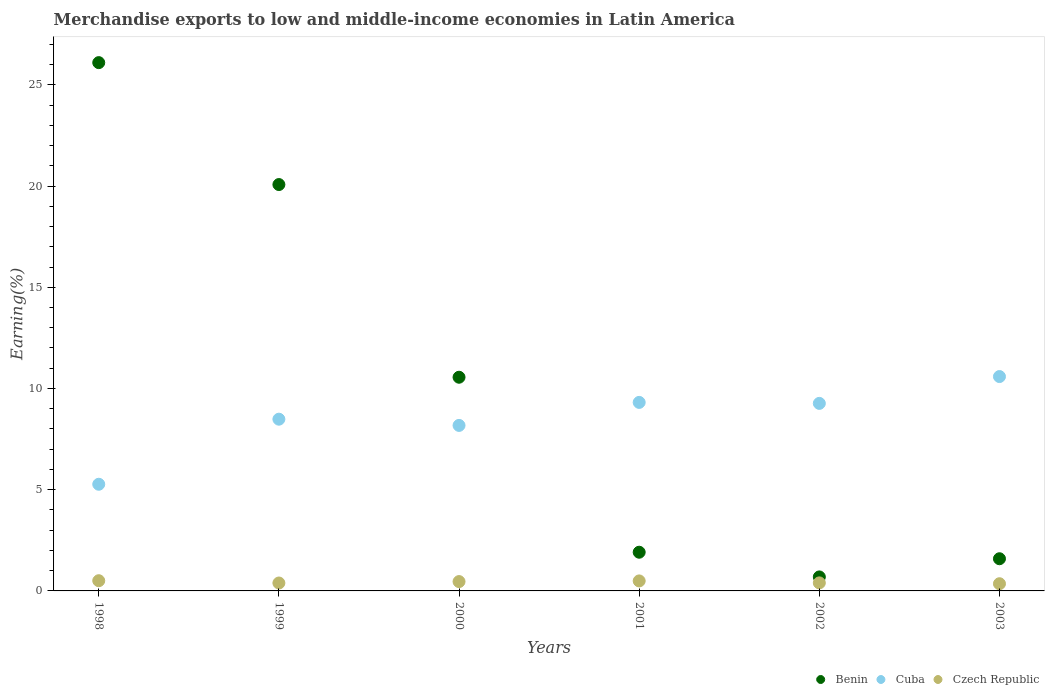Is the number of dotlines equal to the number of legend labels?
Keep it short and to the point. Yes. What is the percentage of amount earned from merchandise exports in Benin in 2000?
Make the answer very short. 10.56. Across all years, what is the maximum percentage of amount earned from merchandise exports in Czech Republic?
Offer a terse response. 0.5. Across all years, what is the minimum percentage of amount earned from merchandise exports in Cuba?
Make the answer very short. 5.27. In which year was the percentage of amount earned from merchandise exports in Czech Republic maximum?
Your response must be concise. 1998. What is the total percentage of amount earned from merchandise exports in Cuba in the graph?
Your response must be concise. 51.09. What is the difference between the percentage of amount earned from merchandise exports in Cuba in 1999 and that in 2000?
Offer a very short reply. 0.31. What is the difference between the percentage of amount earned from merchandise exports in Czech Republic in 2000 and the percentage of amount earned from merchandise exports in Benin in 2001?
Offer a very short reply. -1.45. What is the average percentage of amount earned from merchandise exports in Benin per year?
Your answer should be compact. 10.15. In the year 2001, what is the difference between the percentage of amount earned from merchandise exports in Benin and percentage of amount earned from merchandise exports in Czech Republic?
Provide a short and direct response. 1.42. In how many years, is the percentage of amount earned from merchandise exports in Benin greater than 5 %?
Give a very brief answer. 3. What is the ratio of the percentage of amount earned from merchandise exports in Czech Republic in 1999 to that in 2002?
Provide a succinct answer. 0.98. Is the difference between the percentage of amount earned from merchandise exports in Benin in 1998 and 1999 greater than the difference between the percentage of amount earned from merchandise exports in Czech Republic in 1998 and 1999?
Your answer should be compact. Yes. What is the difference between the highest and the second highest percentage of amount earned from merchandise exports in Benin?
Your answer should be compact. 6.02. What is the difference between the highest and the lowest percentage of amount earned from merchandise exports in Czech Republic?
Your answer should be compact. 0.15. Is the sum of the percentage of amount earned from merchandise exports in Cuba in 2002 and 2003 greater than the maximum percentage of amount earned from merchandise exports in Czech Republic across all years?
Ensure brevity in your answer.  Yes. Is it the case that in every year, the sum of the percentage of amount earned from merchandise exports in Cuba and percentage of amount earned from merchandise exports in Benin  is greater than the percentage of amount earned from merchandise exports in Czech Republic?
Your response must be concise. Yes. How many dotlines are there?
Provide a short and direct response. 3. What is the difference between two consecutive major ticks on the Y-axis?
Give a very brief answer. 5. Does the graph contain any zero values?
Give a very brief answer. No. How many legend labels are there?
Provide a short and direct response. 3. How are the legend labels stacked?
Your response must be concise. Horizontal. What is the title of the graph?
Offer a very short reply. Merchandise exports to low and middle-income economies in Latin America. Does "Morocco" appear as one of the legend labels in the graph?
Make the answer very short. No. What is the label or title of the Y-axis?
Provide a succinct answer. Earning(%). What is the Earning(%) of Benin in 1998?
Give a very brief answer. 26.1. What is the Earning(%) in Cuba in 1998?
Ensure brevity in your answer.  5.27. What is the Earning(%) of Czech Republic in 1998?
Your answer should be compact. 0.5. What is the Earning(%) in Benin in 1999?
Your answer should be compact. 20.07. What is the Earning(%) in Cuba in 1999?
Provide a succinct answer. 8.48. What is the Earning(%) of Czech Republic in 1999?
Keep it short and to the point. 0.39. What is the Earning(%) in Benin in 2000?
Ensure brevity in your answer.  10.56. What is the Earning(%) of Cuba in 2000?
Your response must be concise. 8.18. What is the Earning(%) in Czech Republic in 2000?
Provide a succinct answer. 0.46. What is the Earning(%) of Benin in 2001?
Provide a short and direct response. 1.91. What is the Earning(%) of Cuba in 2001?
Make the answer very short. 9.31. What is the Earning(%) of Czech Republic in 2001?
Make the answer very short. 0.49. What is the Earning(%) in Benin in 2002?
Ensure brevity in your answer.  0.69. What is the Earning(%) in Cuba in 2002?
Keep it short and to the point. 9.26. What is the Earning(%) of Czech Republic in 2002?
Offer a very short reply. 0.4. What is the Earning(%) in Benin in 2003?
Keep it short and to the point. 1.59. What is the Earning(%) in Cuba in 2003?
Your answer should be very brief. 10.59. What is the Earning(%) of Czech Republic in 2003?
Make the answer very short. 0.36. Across all years, what is the maximum Earning(%) in Benin?
Provide a succinct answer. 26.1. Across all years, what is the maximum Earning(%) of Cuba?
Ensure brevity in your answer.  10.59. Across all years, what is the maximum Earning(%) in Czech Republic?
Offer a very short reply. 0.5. Across all years, what is the minimum Earning(%) in Benin?
Ensure brevity in your answer.  0.69. Across all years, what is the minimum Earning(%) in Cuba?
Your answer should be compact. 5.27. Across all years, what is the minimum Earning(%) of Czech Republic?
Make the answer very short. 0.36. What is the total Earning(%) in Benin in the graph?
Provide a short and direct response. 60.92. What is the total Earning(%) of Cuba in the graph?
Ensure brevity in your answer.  51.09. What is the total Earning(%) of Czech Republic in the graph?
Keep it short and to the point. 2.6. What is the difference between the Earning(%) of Benin in 1998 and that in 1999?
Offer a very short reply. 6.02. What is the difference between the Earning(%) of Cuba in 1998 and that in 1999?
Offer a very short reply. -3.21. What is the difference between the Earning(%) in Czech Republic in 1998 and that in 1999?
Provide a succinct answer. 0.11. What is the difference between the Earning(%) of Benin in 1998 and that in 2000?
Ensure brevity in your answer.  15.54. What is the difference between the Earning(%) of Cuba in 1998 and that in 2000?
Keep it short and to the point. -2.91. What is the difference between the Earning(%) of Czech Republic in 1998 and that in 2000?
Your answer should be very brief. 0.04. What is the difference between the Earning(%) of Benin in 1998 and that in 2001?
Give a very brief answer. 24.18. What is the difference between the Earning(%) of Cuba in 1998 and that in 2001?
Provide a succinct answer. -4.04. What is the difference between the Earning(%) in Czech Republic in 1998 and that in 2001?
Ensure brevity in your answer.  0.01. What is the difference between the Earning(%) in Benin in 1998 and that in 2002?
Provide a short and direct response. 25.4. What is the difference between the Earning(%) of Cuba in 1998 and that in 2002?
Your answer should be compact. -4. What is the difference between the Earning(%) in Czech Republic in 1998 and that in 2002?
Your answer should be very brief. 0.11. What is the difference between the Earning(%) of Benin in 1998 and that in 2003?
Make the answer very short. 24.51. What is the difference between the Earning(%) of Cuba in 1998 and that in 2003?
Your answer should be very brief. -5.32. What is the difference between the Earning(%) of Czech Republic in 1998 and that in 2003?
Give a very brief answer. 0.15. What is the difference between the Earning(%) in Benin in 1999 and that in 2000?
Your answer should be compact. 9.52. What is the difference between the Earning(%) of Cuba in 1999 and that in 2000?
Keep it short and to the point. 0.31. What is the difference between the Earning(%) in Czech Republic in 1999 and that in 2000?
Ensure brevity in your answer.  -0.07. What is the difference between the Earning(%) of Benin in 1999 and that in 2001?
Give a very brief answer. 18.16. What is the difference between the Earning(%) of Cuba in 1999 and that in 2001?
Make the answer very short. -0.83. What is the difference between the Earning(%) of Czech Republic in 1999 and that in 2001?
Provide a short and direct response. -0.1. What is the difference between the Earning(%) of Benin in 1999 and that in 2002?
Ensure brevity in your answer.  19.38. What is the difference between the Earning(%) of Cuba in 1999 and that in 2002?
Your answer should be compact. -0.78. What is the difference between the Earning(%) in Czech Republic in 1999 and that in 2002?
Ensure brevity in your answer.  -0.01. What is the difference between the Earning(%) of Benin in 1999 and that in 2003?
Keep it short and to the point. 18.48. What is the difference between the Earning(%) in Cuba in 1999 and that in 2003?
Ensure brevity in your answer.  -2.11. What is the difference between the Earning(%) in Czech Republic in 1999 and that in 2003?
Ensure brevity in your answer.  0.04. What is the difference between the Earning(%) of Benin in 2000 and that in 2001?
Offer a terse response. 8.64. What is the difference between the Earning(%) in Cuba in 2000 and that in 2001?
Keep it short and to the point. -1.14. What is the difference between the Earning(%) of Czech Republic in 2000 and that in 2001?
Your answer should be very brief. -0.03. What is the difference between the Earning(%) in Benin in 2000 and that in 2002?
Your response must be concise. 9.86. What is the difference between the Earning(%) in Cuba in 2000 and that in 2002?
Offer a very short reply. -1.09. What is the difference between the Earning(%) of Czech Republic in 2000 and that in 2002?
Offer a terse response. 0.06. What is the difference between the Earning(%) of Benin in 2000 and that in 2003?
Provide a succinct answer. 8.97. What is the difference between the Earning(%) of Cuba in 2000 and that in 2003?
Keep it short and to the point. -2.41. What is the difference between the Earning(%) of Czech Republic in 2000 and that in 2003?
Offer a terse response. 0.11. What is the difference between the Earning(%) in Benin in 2001 and that in 2002?
Make the answer very short. 1.22. What is the difference between the Earning(%) of Cuba in 2001 and that in 2002?
Make the answer very short. 0.05. What is the difference between the Earning(%) in Czech Republic in 2001 and that in 2002?
Ensure brevity in your answer.  0.1. What is the difference between the Earning(%) of Benin in 2001 and that in 2003?
Your response must be concise. 0.32. What is the difference between the Earning(%) in Cuba in 2001 and that in 2003?
Provide a succinct answer. -1.28. What is the difference between the Earning(%) in Czech Republic in 2001 and that in 2003?
Make the answer very short. 0.14. What is the difference between the Earning(%) of Benin in 2002 and that in 2003?
Keep it short and to the point. -0.9. What is the difference between the Earning(%) of Cuba in 2002 and that in 2003?
Offer a very short reply. -1.32. What is the difference between the Earning(%) in Czech Republic in 2002 and that in 2003?
Your response must be concise. 0.04. What is the difference between the Earning(%) of Benin in 1998 and the Earning(%) of Cuba in 1999?
Keep it short and to the point. 17.61. What is the difference between the Earning(%) in Benin in 1998 and the Earning(%) in Czech Republic in 1999?
Offer a terse response. 25.7. What is the difference between the Earning(%) in Cuba in 1998 and the Earning(%) in Czech Republic in 1999?
Make the answer very short. 4.88. What is the difference between the Earning(%) in Benin in 1998 and the Earning(%) in Cuba in 2000?
Ensure brevity in your answer.  17.92. What is the difference between the Earning(%) in Benin in 1998 and the Earning(%) in Czech Republic in 2000?
Make the answer very short. 25.63. What is the difference between the Earning(%) of Cuba in 1998 and the Earning(%) of Czech Republic in 2000?
Offer a terse response. 4.81. What is the difference between the Earning(%) of Benin in 1998 and the Earning(%) of Cuba in 2001?
Keep it short and to the point. 16.78. What is the difference between the Earning(%) of Benin in 1998 and the Earning(%) of Czech Republic in 2001?
Offer a very short reply. 25.6. What is the difference between the Earning(%) in Cuba in 1998 and the Earning(%) in Czech Republic in 2001?
Ensure brevity in your answer.  4.77. What is the difference between the Earning(%) in Benin in 1998 and the Earning(%) in Cuba in 2002?
Keep it short and to the point. 16.83. What is the difference between the Earning(%) of Benin in 1998 and the Earning(%) of Czech Republic in 2002?
Your answer should be compact. 25.7. What is the difference between the Earning(%) of Cuba in 1998 and the Earning(%) of Czech Republic in 2002?
Provide a short and direct response. 4.87. What is the difference between the Earning(%) in Benin in 1998 and the Earning(%) in Cuba in 2003?
Provide a succinct answer. 15.51. What is the difference between the Earning(%) of Benin in 1998 and the Earning(%) of Czech Republic in 2003?
Your response must be concise. 25.74. What is the difference between the Earning(%) of Cuba in 1998 and the Earning(%) of Czech Republic in 2003?
Make the answer very short. 4.91. What is the difference between the Earning(%) of Benin in 1999 and the Earning(%) of Cuba in 2000?
Offer a very short reply. 11.9. What is the difference between the Earning(%) of Benin in 1999 and the Earning(%) of Czech Republic in 2000?
Offer a terse response. 19.61. What is the difference between the Earning(%) in Cuba in 1999 and the Earning(%) in Czech Republic in 2000?
Your response must be concise. 8.02. What is the difference between the Earning(%) of Benin in 1999 and the Earning(%) of Cuba in 2001?
Provide a short and direct response. 10.76. What is the difference between the Earning(%) in Benin in 1999 and the Earning(%) in Czech Republic in 2001?
Your response must be concise. 19.58. What is the difference between the Earning(%) in Cuba in 1999 and the Earning(%) in Czech Republic in 2001?
Your answer should be very brief. 7.99. What is the difference between the Earning(%) of Benin in 1999 and the Earning(%) of Cuba in 2002?
Give a very brief answer. 10.81. What is the difference between the Earning(%) of Benin in 1999 and the Earning(%) of Czech Republic in 2002?
Offer a very short reply. 19.68. What is the difference between the Earning(%) of Cuba in 1999 and the Earning(%) of Czech Republic in 2002?
Give a very brief answer. 8.09. What is the difference between the Earning(%) of Benin in 1999 and the Earning(%) of Cuba in 2003?
Keep it short and to the point. 9.48. What is the difference between the Earning(%) of Benin in 1999 and the Earning(%) of Czech Republic in 2003?
Keep it short and to the point. 19.72. What is the difference between the Earning(%) of Cuba in 1999 and the Earning(%) of Czech Republic in 2003?
Make the answer very short. 8.13. What is the difference between the Earning(%) in Benin in 2000 and the Earning(%) in Cuba in 2001?
Offer a terse response. 1.24. What is the difference between the Earning(%) in Benin in 2000 and the Earning(%) in Czech Republic in 2001?
Your answer should be compact. 10.06. What is the difference between the Earning(%) of Cuba in 2000 and the Earning(%) of Czech Republic in 2001?
Your response must be concise. 7.68. What is the difference between the Earning(%) of Benin in 2000 and the Earning(%) of Cuba in 2002?
Offer a terse response. 1.29. What is the difference between the Earning(%) of Benin in 2000 and the Earning(%) of Czech Republic in 2002?
Ensure brevity in your answer.  10.16. What is the difference between the Earning(%) of Cuba in 2000 and the Earning(%) of Czech Republic in 2002?
Your answer should be compact. 7.78. What is the difference between the Earning(%) of Benin in 2000 and the Earning(%) of Cuba in 2003?
Your response must be concise. -0.03. What is the difference between the Earning(%) in Benin in 2000 and the Earning(%) in Czech Republic in 2003?
Give a very brief answer. 10.2. What is the difference between the Earning(%) of Cuba in 2000 and the Earning(%) of Czech Republic in 2003?
Your response must be concise. 7.82. What is the difference between the Earning(%) of Benin in 2001 and the Earning(%) of Cuba in 2002?
Keep it short and to the point. -7.35. What is the difference between the Earning(%) in Benin in 2001 and the Earning(%) in Czech Republic in 2002?
Offer a terse response. 1.51. What is the difference between the Earning(%) of Cuba in 2001 and the Earning(%) of Czech Republic in 2002?
Your answer should be compact. 8.91. What is the difference between the Earning(%) of Benin in 2001 and the Earning(%) of Cuba in 2003?
Keep it short and to the point. -8.68. What is the difference between the Earning(%) in Benin in 2001 and the Earning(%) in Czech Republic in 2003?
Give a very brief answer. 1.56. What is the difference between the Earning(%) in Cuba in 2001 and the Earning(%) in Czech Republic in 2003?
Provide a short and direct response. 8.96. What is the difference between the Earning(%) of Benin in 2002 and the Earning(%) of Cuba in 2003?
Provide a short and direct response. -9.9. What is the difference between the Earning(%) of Benin in 2002 and the Earning(%) of Czech Republic in 2003?
Offer a very short reply. 0.34. What is the difference between the Earning(%) in Cuba in 2002 and the Earning(%) in Czech Republic in 2003?
Provide a short and direct response. 8.91. What is the average Earning(%) in Benin per year?
Give a very brief answer. 10.15. What is the average Earning(%) in Cuba per year?
Your response must be concise. 8.52. What is the average Earning(%) in Czech Republic per year?
Your answer should be very brief. 0.43. In the year 1998, what is the difference between the Earning(%) in Benin and Earning(%) in Cuba?
Your answer should be very brief. 20.83. In the year 1998, what is the difference between the Earning(%) in Benin and Earning(%) in Czech Republic?
Provide a succinct answer. 25.59. In the year 1998, what is the difference between the Earning(%) in Cuba and Earning(%) in Czech Republic?
Provide a succinct answer. 4.76. In the year 1999, what is the difference between the Earning(%) of Benin and Earning(%) of Cuba?
Offer a terse response. 11.59. In the year 1999, what is the difference between the Earning(%) in Benin and Earning(%) in Czech Republic?
Your answer should be very brief. 19.68. In the year 1999, what is the difference between the Earning(%) in Cuba and Earning(%) in Czech Republic?
Keep it short and to the point. 8.09. In the year 2000, what is the difference between the Earning(%) of Benin and Earning(%) of Cuba?
Your answer should be very brief. 2.38. In the year 2000, what is the difference between the Earning(%) of Benin and Earning(%) of Czech Republic?
Your answer should be compact. 10.09. In the year 2000, what is the difference between the Earning(%) in Cuba and Earning(%) in Czech Republic?
Keep it short and to the point. 7.71. In the year 2001, what is the difference between the Earning(%) in Benin and Earning(%) in Cuba?
Give a very brief answer. -7.4. In the year 2001, what is the difference between the Earning(%) of Benin and Earning(%) of Czech Republic?
Offer a terse response. 1.42. In the year 2001, what is the difference between the Earning(%) of Cuba and Earning(%) of Czech Republic?
Give a very brief answer. 8.82. In the year 2002, what is the difference between the Earning(%) in Benin and Earning(%) in Cuba?
Make the answer very short. -8.57. In the year 2002, what is the difference between the Earning(%) of Benin and Earning(%) of Czech Republic?
Your response must be concise. 0.29. In the year 2002, what is the difference between the Earning(%) in Cuba and Earning(%) in Czech Republic?
Make the answer very short. 8.87. In the year 2003, what is the difference between the Earning(%) of Benin and Earning(%) of Cuba?
Your response must be concise. -9. In the year 2003, what is the difference between the Earning(%) in Benin and Earning(%) in Czech Republic?
Offer a terse response. 1.23. In the year 2003, what is the difference between the Earning(%) in Cuba and Earning(%) in Czech Republic?
Make the answer very short. 10.23. What is the ratio of the Earning(%) in Cuba in 1998 to that in 1999?
Your answer should be compact. 0.62. What is the ratio of the Earning(%) of Czech Republic in 1998 to that in 1999?
Provide a short and direct response. 1.29. What is the ratio of the Earning(%) in Benin in 1998 to that in 2000?
Offer a very short reply. 2.47. What is the ratio of the Earning(%) in Cuba in 1998 to that in 2000?
Give a very brief answer. 0.64. What is the ratio of the Earning(%) of Czech Republic in 1998 to that in 2000?
Provide a succinct answer. 1.09. What is the ratio of the Earning(%) of Benin in 1998 to that in 2001?
Ensure brevity in your answer.  13.65. What is the ratio of the Earning(%) in Cuba in 1998 to that in 2001?
Provide a succinct answer. 0.57. What is the ratio of the Earning(%) in Czech Republic in 1998 to that in 2001?
Offer a terse response. 1.02. What is the ratio of the Earning(%) in Benin in 1998 to that in 2002?
Provide a short and direct response. 37.73. What is the ratio of the Earning(%) in Cuba in 1998 to that in 2002?
Your answer should be very brief. 0.57. What is the ratio of the Earning(%) of Czech Republic in 1998 to that in 2002?
Offer a terse response. 1.27. What is the ratio of the Earning(%) of Benin in 1998 to that in 2003?
Provide a succinct answer. 16.42. What is the ratio of the Earning(%) in Cuba in 1998 to that in 2003?
Make the answer very short. 0.5. What is the ratio of the Earning(%) in Czech Republic in 1998 to that in 2003?
Provide a succinct answer. 1.42. What is the ratio of the Earning(%) of Benin in 1999 to that in 2000?
Your answer should be very brief. 1.9. What is the ratio of the Earning(%) of Cuba in 1999 to that in 2000?
Your answer should be very brief. 1.04. What is the ratio of the Earning(%) in Czech Republic in 1999 to that in 2000?
Your answer should be compact. 0.85. What is the ratio of the Earning(%) in Benin in 1999 to that in 2001?
Your response must be concise. 10.5. What is the ratio of the Earning(%) in Cuba in 1999 to that in 2001?
Provide a succinct answer. 0.91. What is the ratio of the Earning(%) of Czech Republic in 1999 to that in 2001?
Your answer should be compact. 0.79. What is the ratio of the Earning(%) of Benin in 1999 to that in 2002?
Your answer should be very brief. 29.02. What is the ratio of the Earning(%) of Cuba in 1999 to that in 2002?
Provide a short and direct response. 0.92. What is the ratio of the Earning(%) in Czech Republic in 1999 to that in 2002?
Ensure brevity in your answer.  0.98. What is the ratio of the Earning(%) of Benin in 1999 to that in 2003?
Your answer should be compact. 12.63. What is the ratio of the Earning(%) of Cuba in 1999 to that in 2003?
Provide a succinct answer. 0.8. What is the ratio of the Earning(%) in Czech Republic in 1999 to that in 2003?
Your answer should be compact. 1.1. What is the ratio of the Earning(%) in Benin in 2000 to that in 2001?
Offer a very short reply. 5.52. What is the ratio of the Earning(%) of Cuba in 2000 to that in 2001?
Provide a succinct answer. 0.88. What is the ratio of the Earning(%) of Czech Republic in 2000 to that in 2001?
Make the answer very short. 0.93. What is the ratio of the Earning(%) of Benin in 2000 to that in 2002?
Make the answer very short. 15.26. What is the ratio of the Earning(%) in Cuba in 2000 to that in 2002?
Offer a very short reply. 0.88. What is the ratio of the Earning(%) in Czech Republic in 2000 to that in 2002?
Keep it short and to the point. 1.16. What is the ratio of the Earning(%) of Benin in 2000 to that in 2003?
Provide a short and direct response. 6.64. What is the ratio of the Earning(%) in Cuba in 2000 to that in 2003?
Provide a succinct answer. 0.77. What is the ratio of the Earning(%) of Czech Republic in 2000 to that in 2003?
Offer a terse response. 1.3. What is the ratio of the Earning(%) of Benin in 2001 to that in 2002?
Provide a short and direct response. 2.76. What is the ratio of the Earning(%) in Czech Republic in 2001 to that in 2002?
Make the answer very short. 1.24. What is the ratio of the Earning(%) of Benin in 2001 to that in 2003?
Your response must be concise. 1.2. What is the ratio of the Earning(%) in Cuba in 2001 to that in 2003?
Offer a terse response. 0.88. What is the ratio of the Earning(%) in Czech Republic in 2001 to that in 2003?
Keep it short and to the point. 1.39. What is the ratio of the Earning(%) of Benin in 2002 to that in 2003?
Provide a short and direct response. 0.44. What is the ratio of the Earning(%) of Cuba in 2002 to that in 2003?
Your answer should be very brief. 0.87. What is the ratio of the Earning(%) in Czech Republic in 2002 to that in 2003?
Make the answer very short. 1.12. What is the difference between the highest and the second highest Earning(%) of Benin?
Your answer should be compact. 6.02. What is the difference between the highest and the second highest Earning(%) of Cuba?
Provide a short and direct response. 1.28. What is the difference between the highest and the second highest Earning(%) of Czech Republic?
Your response must be concise. 0.01. What is the difference between the highest and the lowest Earning(%) in Benin?
Give a very brief answer. 25.4. What is the difference between the highest and the lowest Earning(%) in Cuba?
Give a very brief answer. 5.32. What is the difference between the highest and the lowest Earning(%) of Czech Republic?
Make the answer very short. 0.15. 